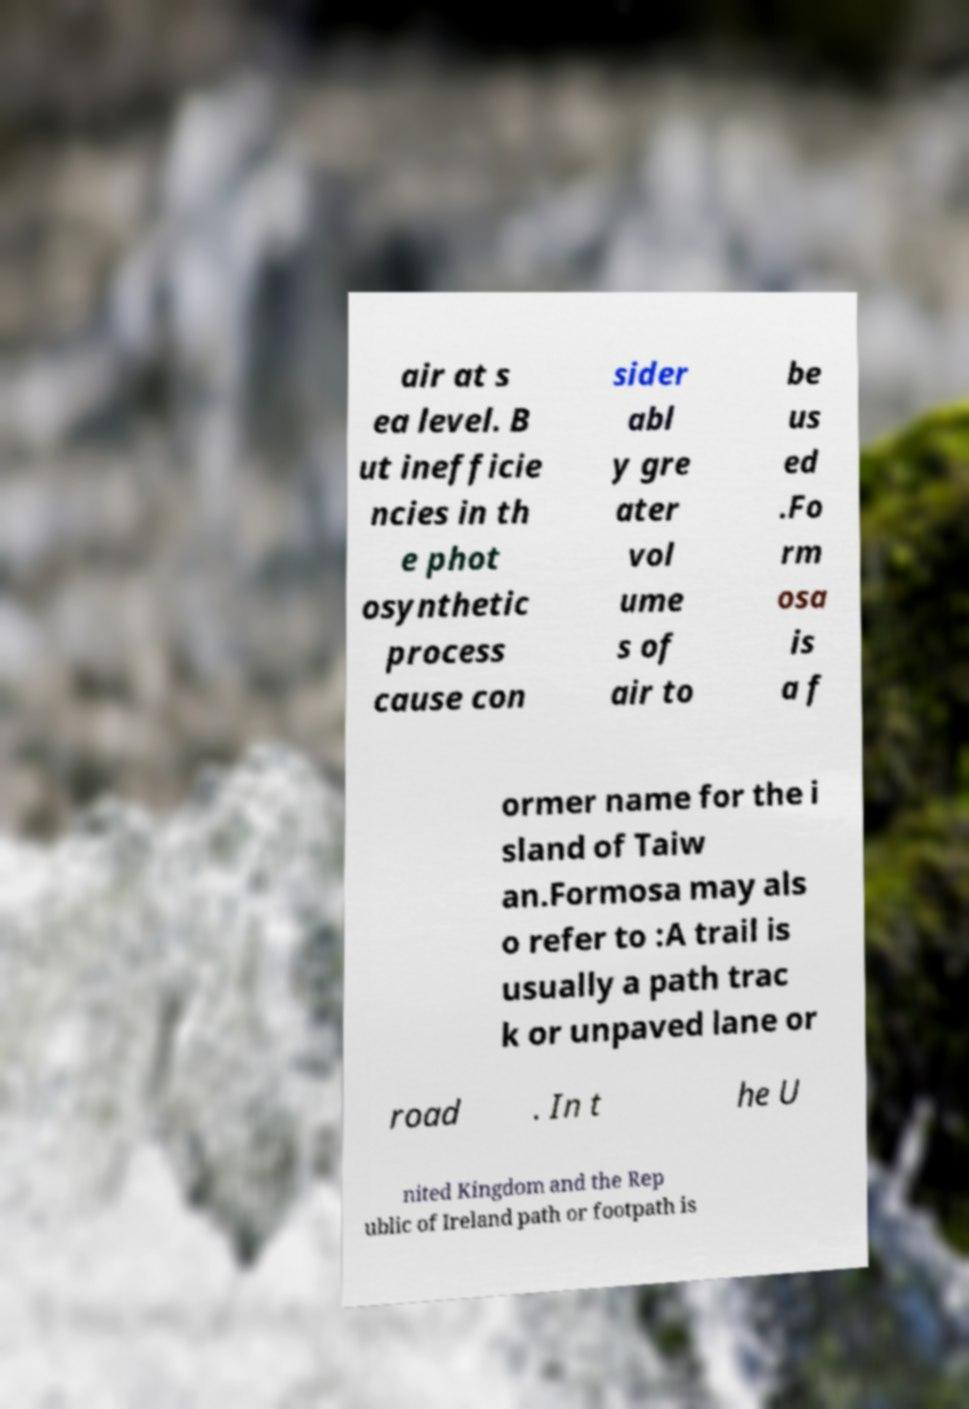For documentation purposes, I need the text within this image transcribed. Could you provide that? air at s ea level. B ut inefficie ncies in th e phot osynthetic process cause con sider abl y gre ater vol ume s of air to be us ed .Fo rm osa is a f ormer name for the i sland of Taiw an.Formosa may als o refer to :A trail is usually a path trac k or unpaved lane or road . In t he U nited Kingdom and the Rep ublic of Ireland path or footpath is 